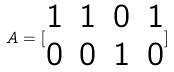<formula> <loc_0><loc_0><loc_500><loc_500>A = [ \begin{matrix} 1 & 1 & 0 & 1 \\ 0 & 0 & 1 & 0 \end{matrix} ]</formula> 